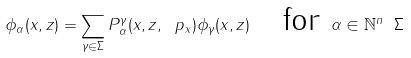<formula> <loc_0><loc_0><loc_500><loc_500>\phi _ { \alpha } ( x , z ) = \sum _ { \gamma \in \Sigma } P _ { \alpha } ^ { \gamma } ( x , z , \ p _ { x } ) \phi _ { \gamma } ( x , z ) \quad \text {for } \alpha \in \mathbb { N } ^ { n } \ \Sigma</formula> 